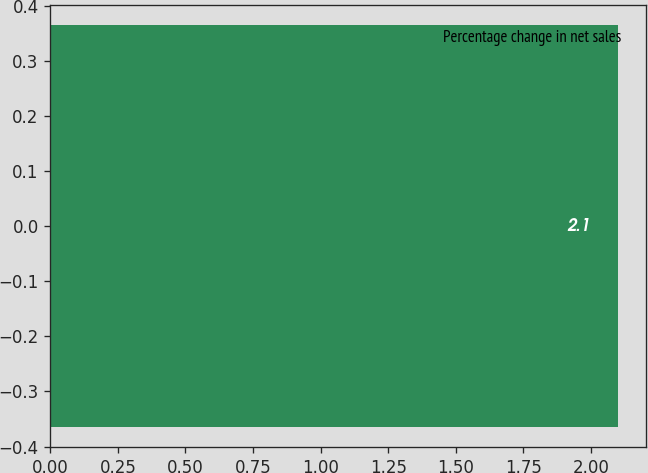Convert chart. <chart><loc_0><loc_0><loc_500><loc_500><bar_chart><fcel>Percentage change in net sales<nl><fcel>2.1<nl></chart> 